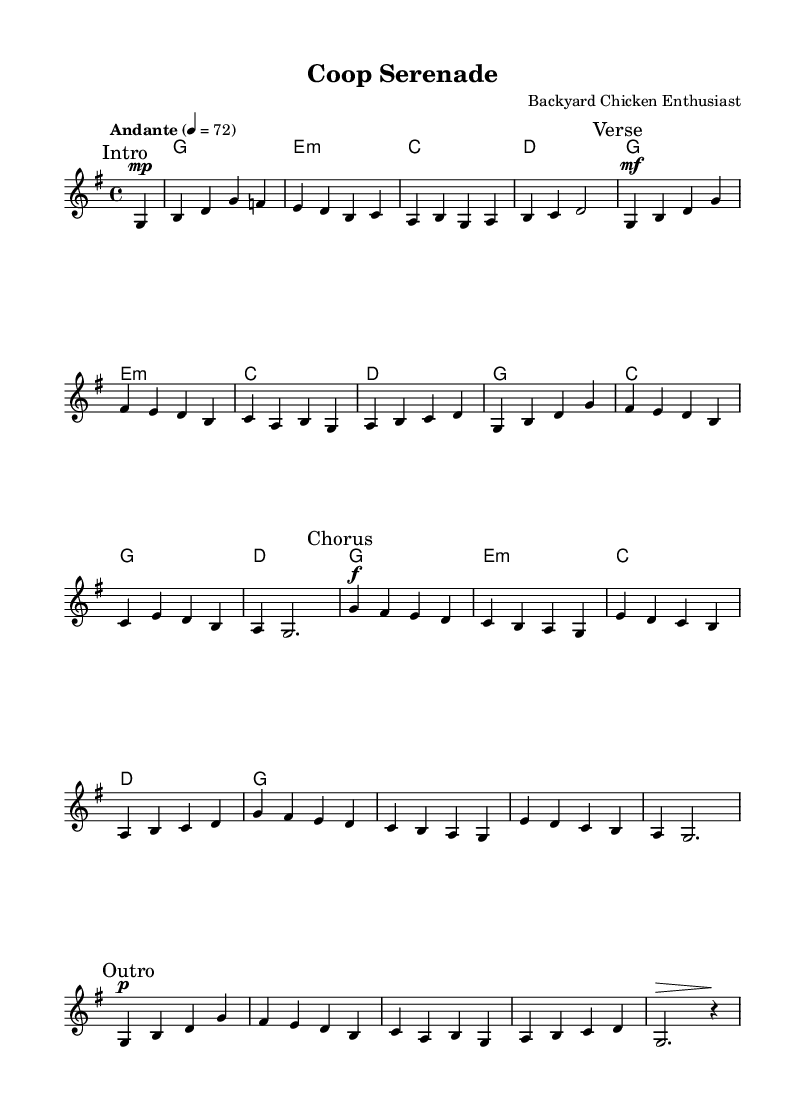What is the key signature of this music? The key signature is G major, which has one sharp (F#).
Answer: G major What is the time signature of the piece? The time signature is 4/4, indicating four beats per measure.
Answer: 4/4 What is the tempo marking for this piece? The tempo marking is "Andante," which suggests a moderately slow pace.
Answer: Andante How many measures are in the verse section? The verse section consists of eight measures as indicated in the music section labeled "Verse."
Answer: Eight measures What dynamic marking is used for the chorus? The dynamic marking for the chorus is "f," which means fortissimo or very loud.
Answer: f How many different chord progressions are played in the harmonies? There are four distinct chord progressions played throughout the piece in the harmonies section.
Answer: Four What is the last dynamic marking before the outro? The last dynamic marking before the outro is "p," which indicates a soft volume.
Answer: p 